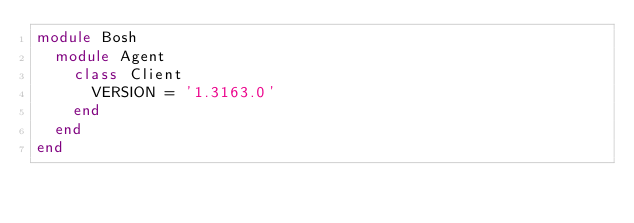<code> <loc_0><loc_0><loc_500><loc_500><_Ruby_>module Bosh
  module Agent
    class Client
      VERSION = '1.3163.0'
    end
  end
end
</code> 